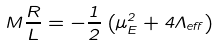Convert formula to latex. <formula><loc_0><loc_0><loc_500><loc_500>M \frac { R } { L } = - \frac { 1 } { 2 } \left ( \mu _ { E } ^ { 2 } + 4 \Lambda _ { e f f } \right )</formula> 